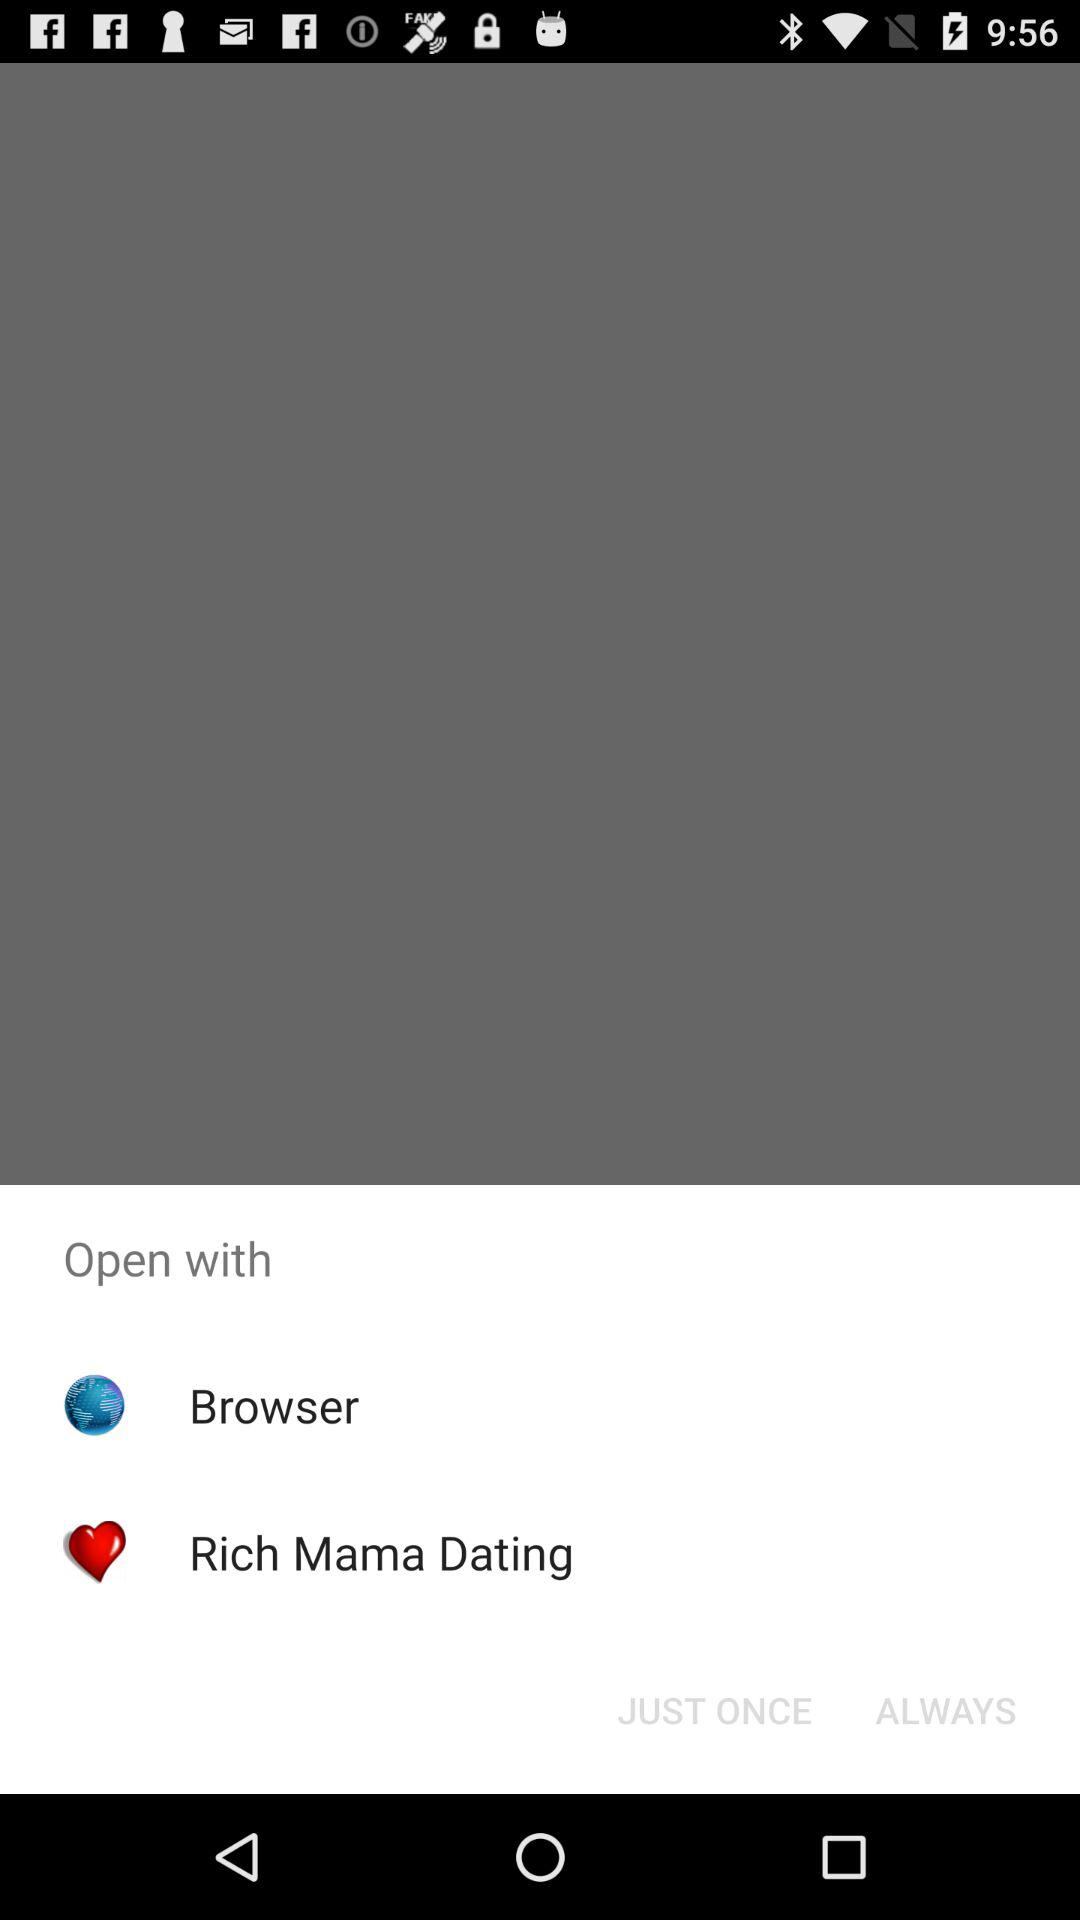What is the name of the application?
When the provided information is insufficient, respond with <no answer>. <no answer> 